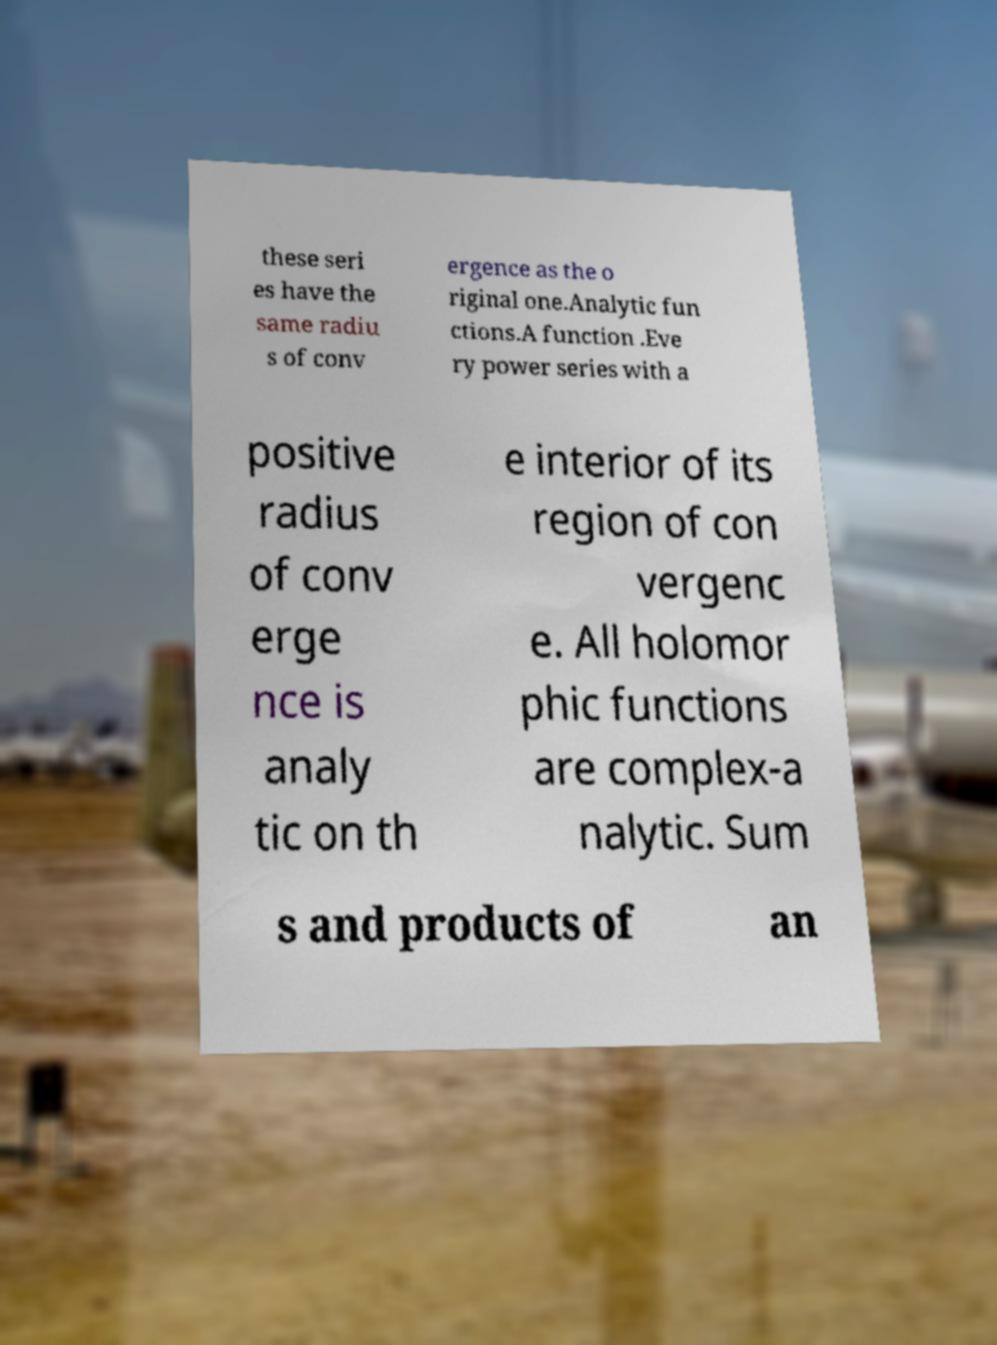Please identify and transcribe the text found in this image. these seri es have the same radiu s of conv ergence as the o riginal one.Analytic fun ctions.A function .Eve ry power series with a positive radius of conv erge nce is analy tic on th e interior of its region of con vergenc e. All holomor phic functions are complex-a nalytic. Sum s and products of an 